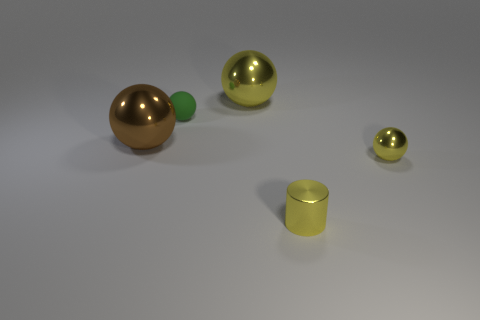Add 1 brown things. How many objects exist? 6 Subtract all blue balls. Subtract all green cylinders. How many balls are left? 4 Subtract all cylinders. How many objects are left? 4 Subtract all tiny matte objects. Subtract all big balls. How many objects are left? 2 Add 4 brown objects. How many brown objects are left? 5 Add 3 big yellow balls. How many big yellow balls exist? 4 Subtract 0 blue spheres. How many objects are left? 5 